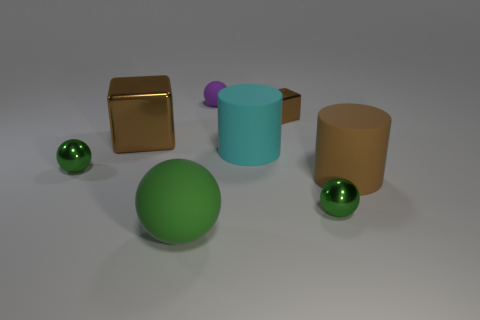Does the matte sphere right of the green rubber thing have the same size as the metal cube to the right of the large brown metallic thing? yes 